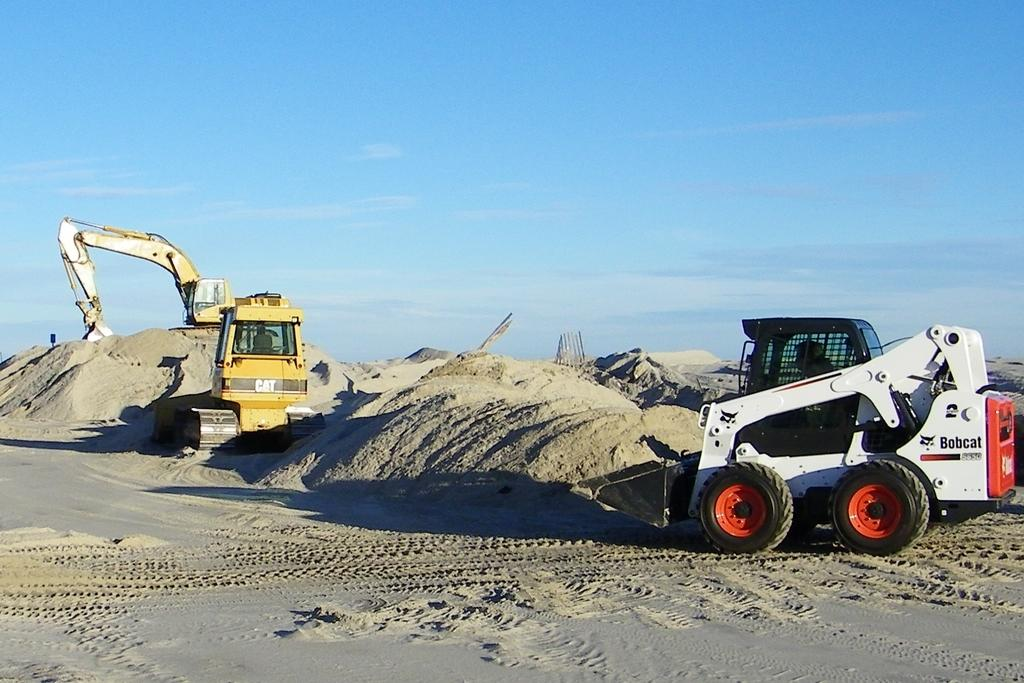What type of vehicles are in the image? There are trucks in the image. Where are the trucks located? The trucks are on the sand. What is visible in the background of the image? There is a sky visible in the background of the image. How many eggs are being used to create the rhythm in the image? There are no eggs or any indication of rhythm present in the image. What historical event is being depicted in the image? There is no historical event being depicted in the image; it features trucks on the sand. 